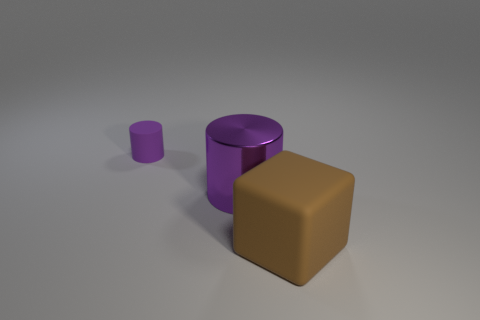Which object in the image is the largest? The largest object in the image is the brown cube, which appears to have a bigger volume compared to the other objects. Can you describe the surface texture of the objects? Certainly, the objects have a matte finish with soft shadows indicating a diffuse surface, which absorbs and scatters light. This gives them a non-glossy appearance without strong reflections. 